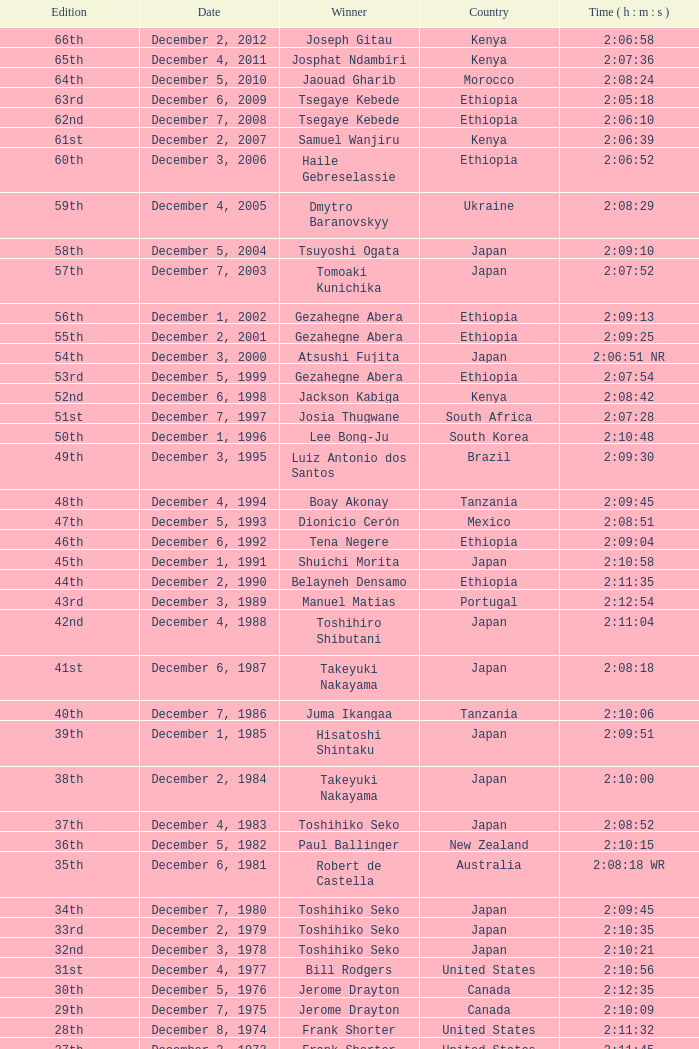On what date did Lee Bong-Ju win in 2:10:48? December 1, 1996. 